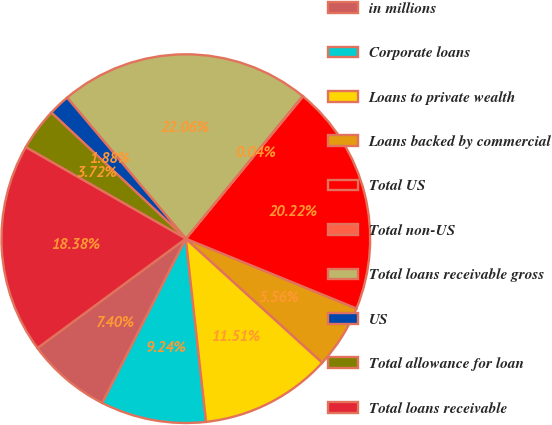<chart> <loc_0><loc_0><loc_500><loc_500><pie_chart><fcel>in millions<fcel>Corporate loans<fcel>Loans to private wealth<fcel>Loans backed by commercial<fcel>Total US<fcel>Total non-US<fcel>Total loans receivable gross<fcel>US<fcel>Total allowance for loan<fcel>Total loans receivable<nl><fcel>7.4%<fcel>9.24%<fcel>11.51%<fcel>5.56%<fcel>20.22%<fcel>0.04%<fcel>22.06%<fcel>1.88%<fcel>3.72%<fcel>18.38%<nl></chart> 